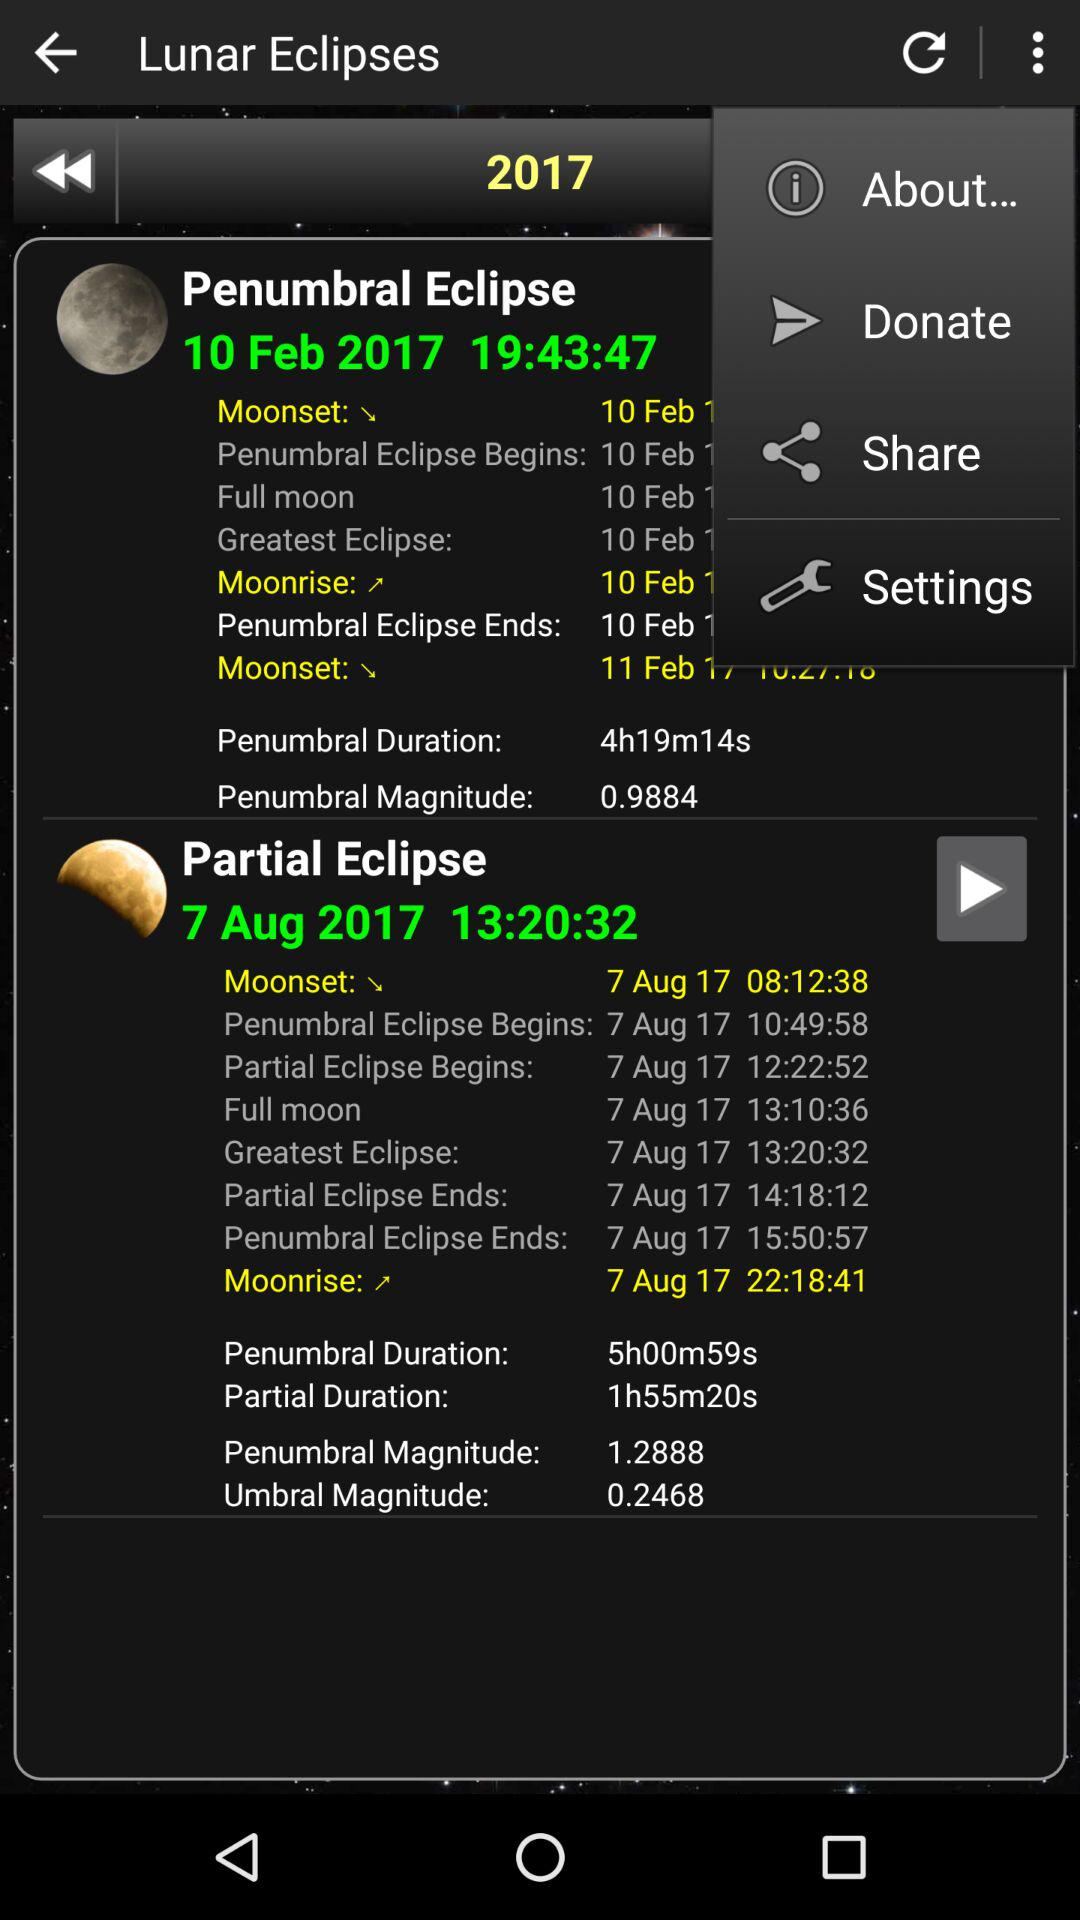What is the time of the penumbral eclipse? The time of the penumbral eclipse is 19:43:47. 